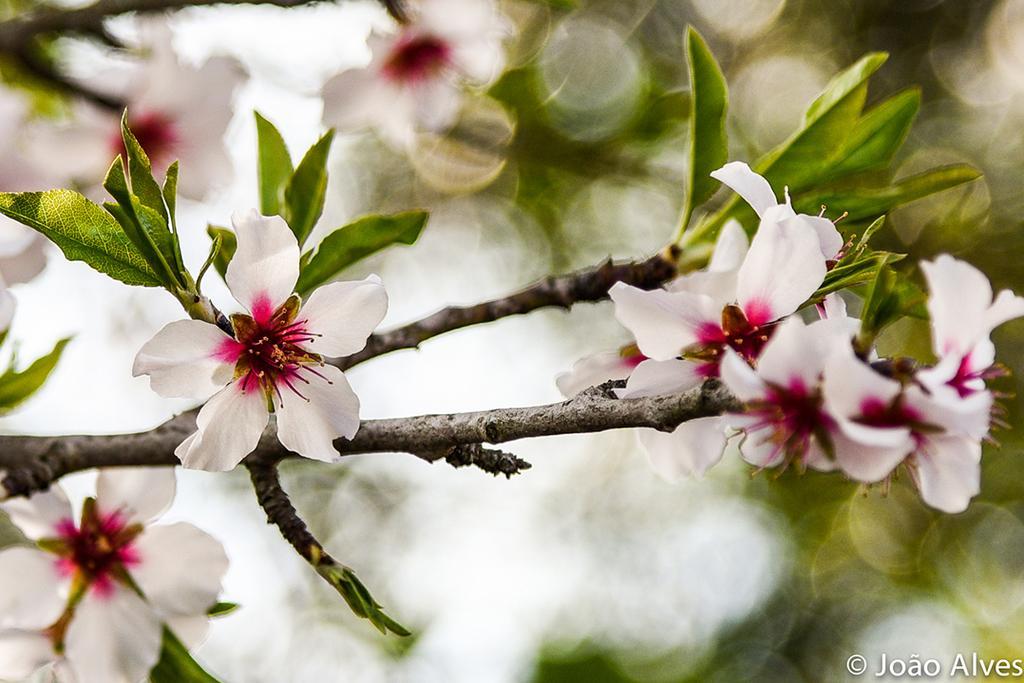How would you summarize this image in a sentence or two? In this picture we can see flowers, leaves and branches. In the background of the image it is blurry. In the bottom right side of the image we can see text. 